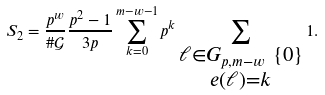<formula> <loc_0><loc_0><loc_500><loc_500>S _ { 2 } = \frac { p ^ { w } } { \# \mathcal { G } } \frac { p ^ { 2 } - 1 } { 3 p } \sum _ { k = 0 } ^ { m - w - 1 } p ^ { k } \sum _ { \substack { \ell \in G _ { p , m - w } \ \{ 0 \} \\ e ( \ell ) = k } } 1 .</formula> 